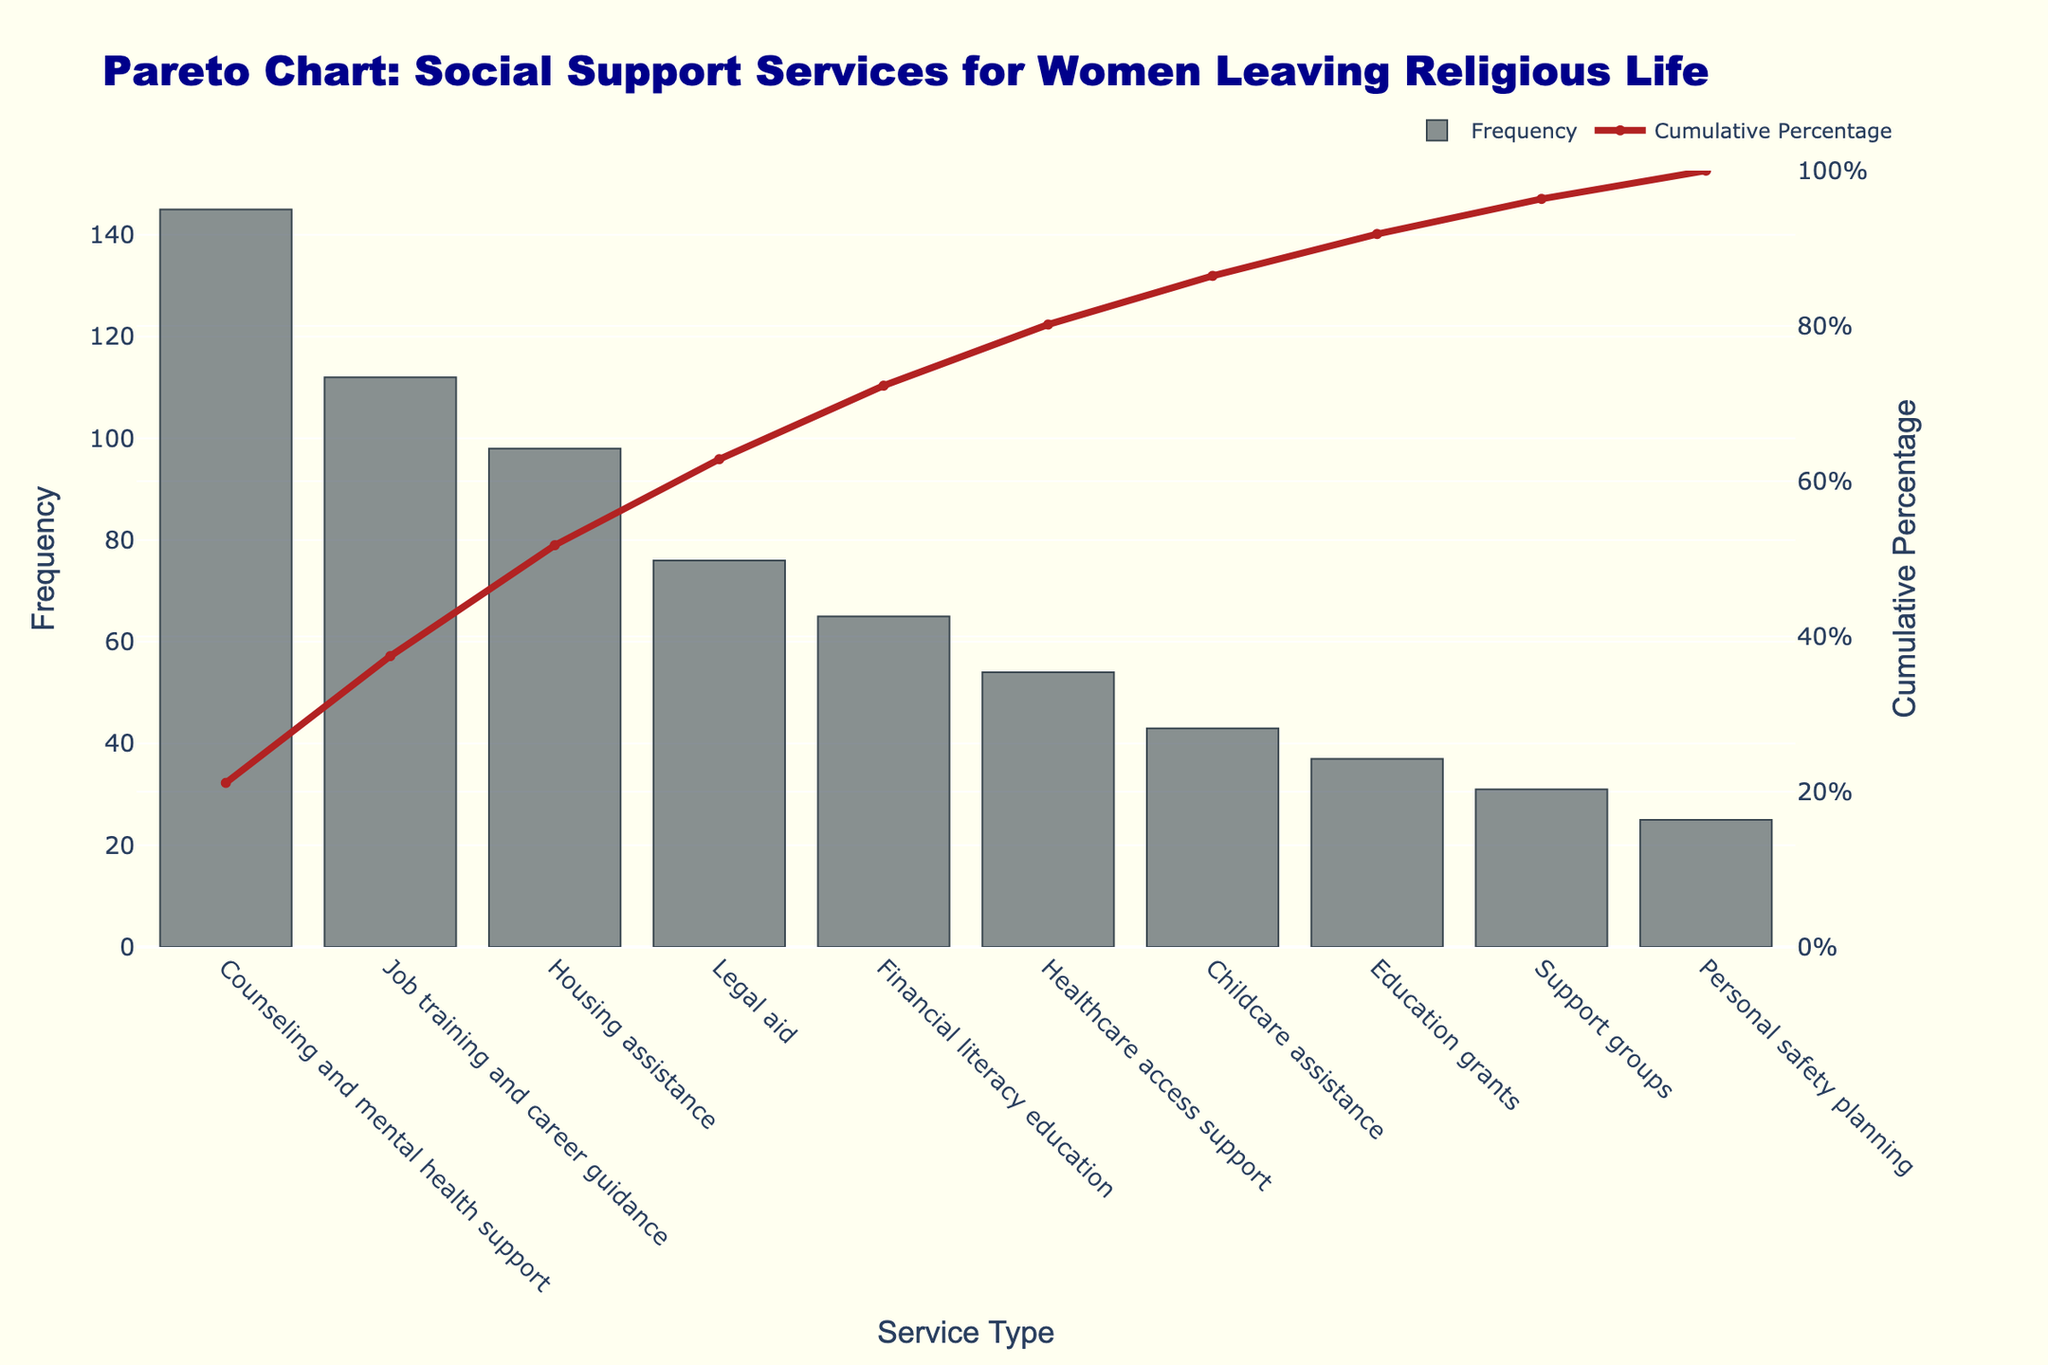What is the type of support service with the highest frequency requested by women who have left religious life? The type of support service with the highest frequency is represented as the tallest bar in the Pareto chart. Looking at the bar heights, "Counseling and mental health support" is the tallest.
Answer: Counseling and mental health support What percentage of the total cumulative frequency does "Job training and career guidance" account for? On the secondary y-axis (right side) of the Pareto chart, find the cumulative percentage marked by the curve. For "Job training and career guidance," the cumulative percentage is approximately 55%.
Answer: 55% How many types of support services have a cumulative percentage of less than or equal to 80%? Follow the cumulative percentage line on the Pareto chart up to 80%. Count the number of services below this mark. "Counseling and mental health support," "Job training and career guidance," "Housing assistance," and "Legal aid" fall below 80%.
Answer: 4 Which service ranks fifth in terms of frequency and what is its frequency? Services are ordered by frequency in the Pareto chart from left to right. The fifth service is "Financial literacy education," and its frequency is the height of the fifth bar.
Answer: Financial literacy education, 65 What is the cumulative percentage after adding "Education grants"? Locate "Education grants" on the x-axis, and follow the cumulative percentage line (secondary y-axis) corresponding to this service. The cumulative percentage at this service is approximately 90%.
Answer: 90% Compare the frequencies of "Healthcare access support" and "Childcare assistance." Which one has a higher frequency? Locate both "Healthcare access support" and "Childcare assistance" on the x-axis. The height of the bar representing "Healthcare access support" (54) is higher than "Childcare assistance" (43).
Answer: Healthcare access support What is the cumulative percentage difference between "Counseling and mental health support" and "Housing assistance"? Follow the cumulative percentage line for both "Counseling and mental health support" (around 30%) and "Housing assistance" (around 70%). Subtract to find the difference.
Answer: 40% How many services have a frequency less than or equal to 50? Identify the bars with a height of 50 or less. "Childcare assistance," "Education grants," "Support groups," and "Personal safety planning" meet this criterion. Count these services.
Answer: 4 If "Legal aid" and "Financial literacy education" frequencies were combined, what would their new total be? Add the frequencies of "Legal aid" (76) and "Financial literacy education" (65) together. 76 + 65 = 141
Answer: 141 What percentage of the total frequency does "Support groups" represent? Total frequency is the sum of the frequencies of all the support services. Sum is 686. The percentage is calculated as (31 / 686) * 100 ≈ 4.5%.
Answer: About 4.5% 